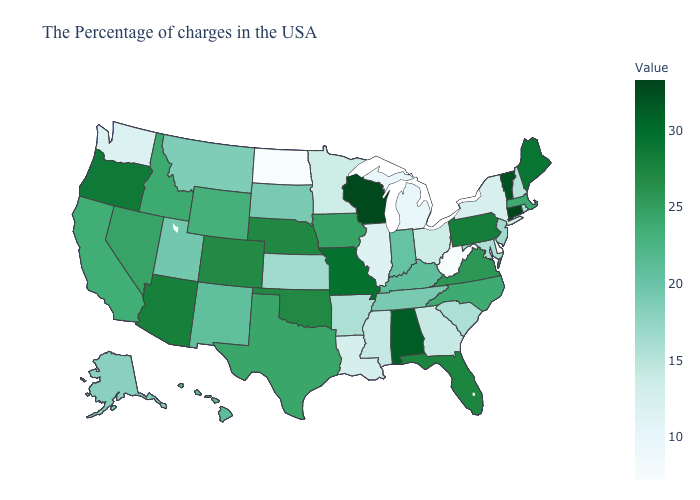Among the states that border Connecticut , does Massachusetts have the lowest value?
Give a very brief answer. No. Which states have the highest value in the USA?
Quick response, please. Connecticut. Which states have the lowest value in the USA?
Keep it brief. West Virginia, North Dakota. Among the states that border Utah , which have the highest value?
Quick response, please. Arizona. Does Colorado have a lower value than Alabama?
Short answer required. Yes. Does Montana have the highest value in the West?
Quick response, please. No. 